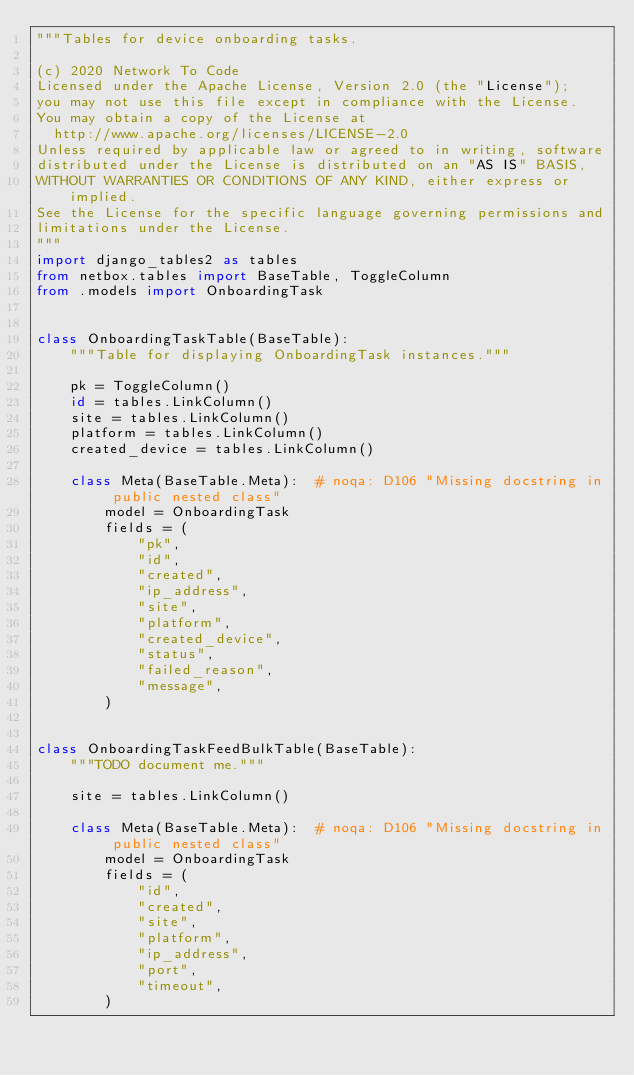<code> <loc_0><loc_0><loc_500><loc_500><_Python_>"""Tables for device onboarding tasks.

(c) 2020 Network To Code
Licensed under the Apache License, Version 2.0 (the "License");
you may not use this file except in compliance with the License.
You may obtain a copy of the License at
  http://www.apache.org/licenses/LICENSE-2.0
Unless required by applicable law or agreed to in writing, software
distributed under the License is distributed on an "AS IS" BASIS,
WITHOUT WARRANTIES OR CONDITIONS OF ANY KIND, either express or implied.
See the License for the specific language governing permissions and
limitations under the License.
"""
import django_tables2 as tables
from netbox.tables import BaseTable, ToggleColumn
from .models import OnboardingTask


class OnboardingTaskTable(BaseTable):
    """Table for displaying OnboardingTask instances."""

    pk = ToggleColumn()
    id = tables.LinkColumn()
    site = tables.LinkColumn()
    platform = tables.LinkColumn()
    created_device = tables.LinkColumn()

    class Meta(BaseTable.Meta):  # noqa: D106 "Missing docstring in public nested class"
        model = OnboardingTask
        fields = (
            "pk",
            "id",
            "created",
            "ip_address",
            "site",
            "platform",
            "created_device",
            "status",
            "failed_reason",
            "message",
        )


class OnboardingTaskFeedBulkTable(BaseTable):
    """TODO document me."""

    site = tables.LinkColumn()

    class Meta(BaseTable.Meta):  # noqa: D106 "Missing docstring in public nested class"
        model = OnboardingTask
        fields = (
            "id",
            "created",
            "site",
            "platform",
            "ip_address",
            "port",
            "timeout",
        )
</code> 